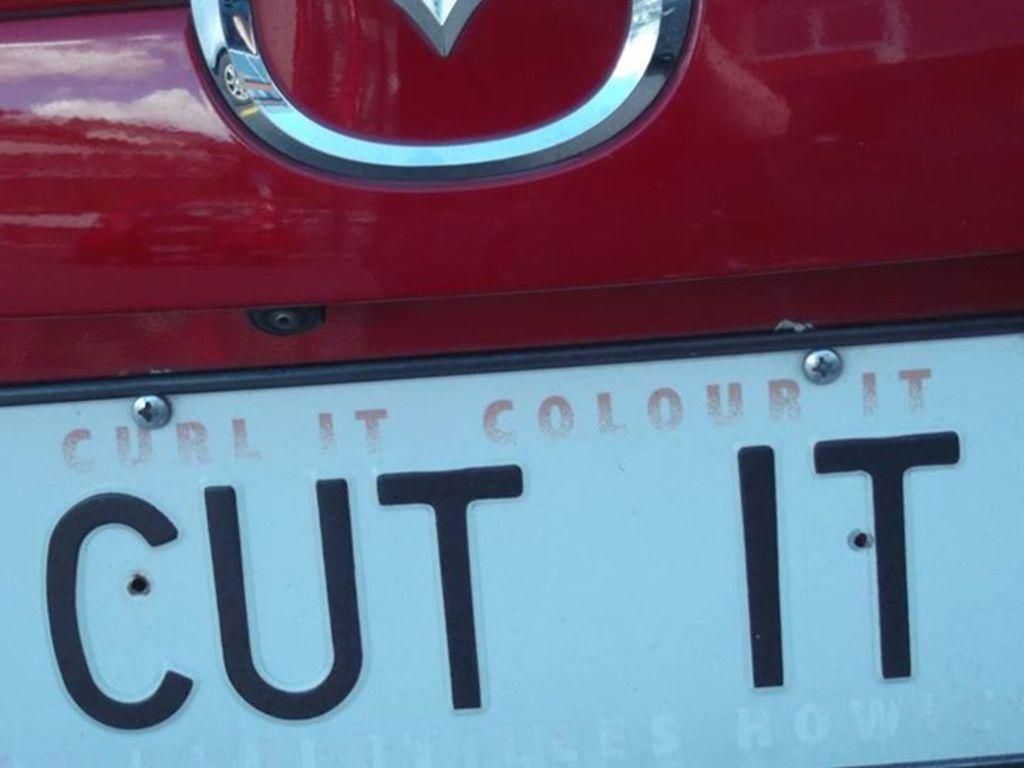<image>
Offer a succinct explanation of the picture presented. a sign that says cut it on a car 